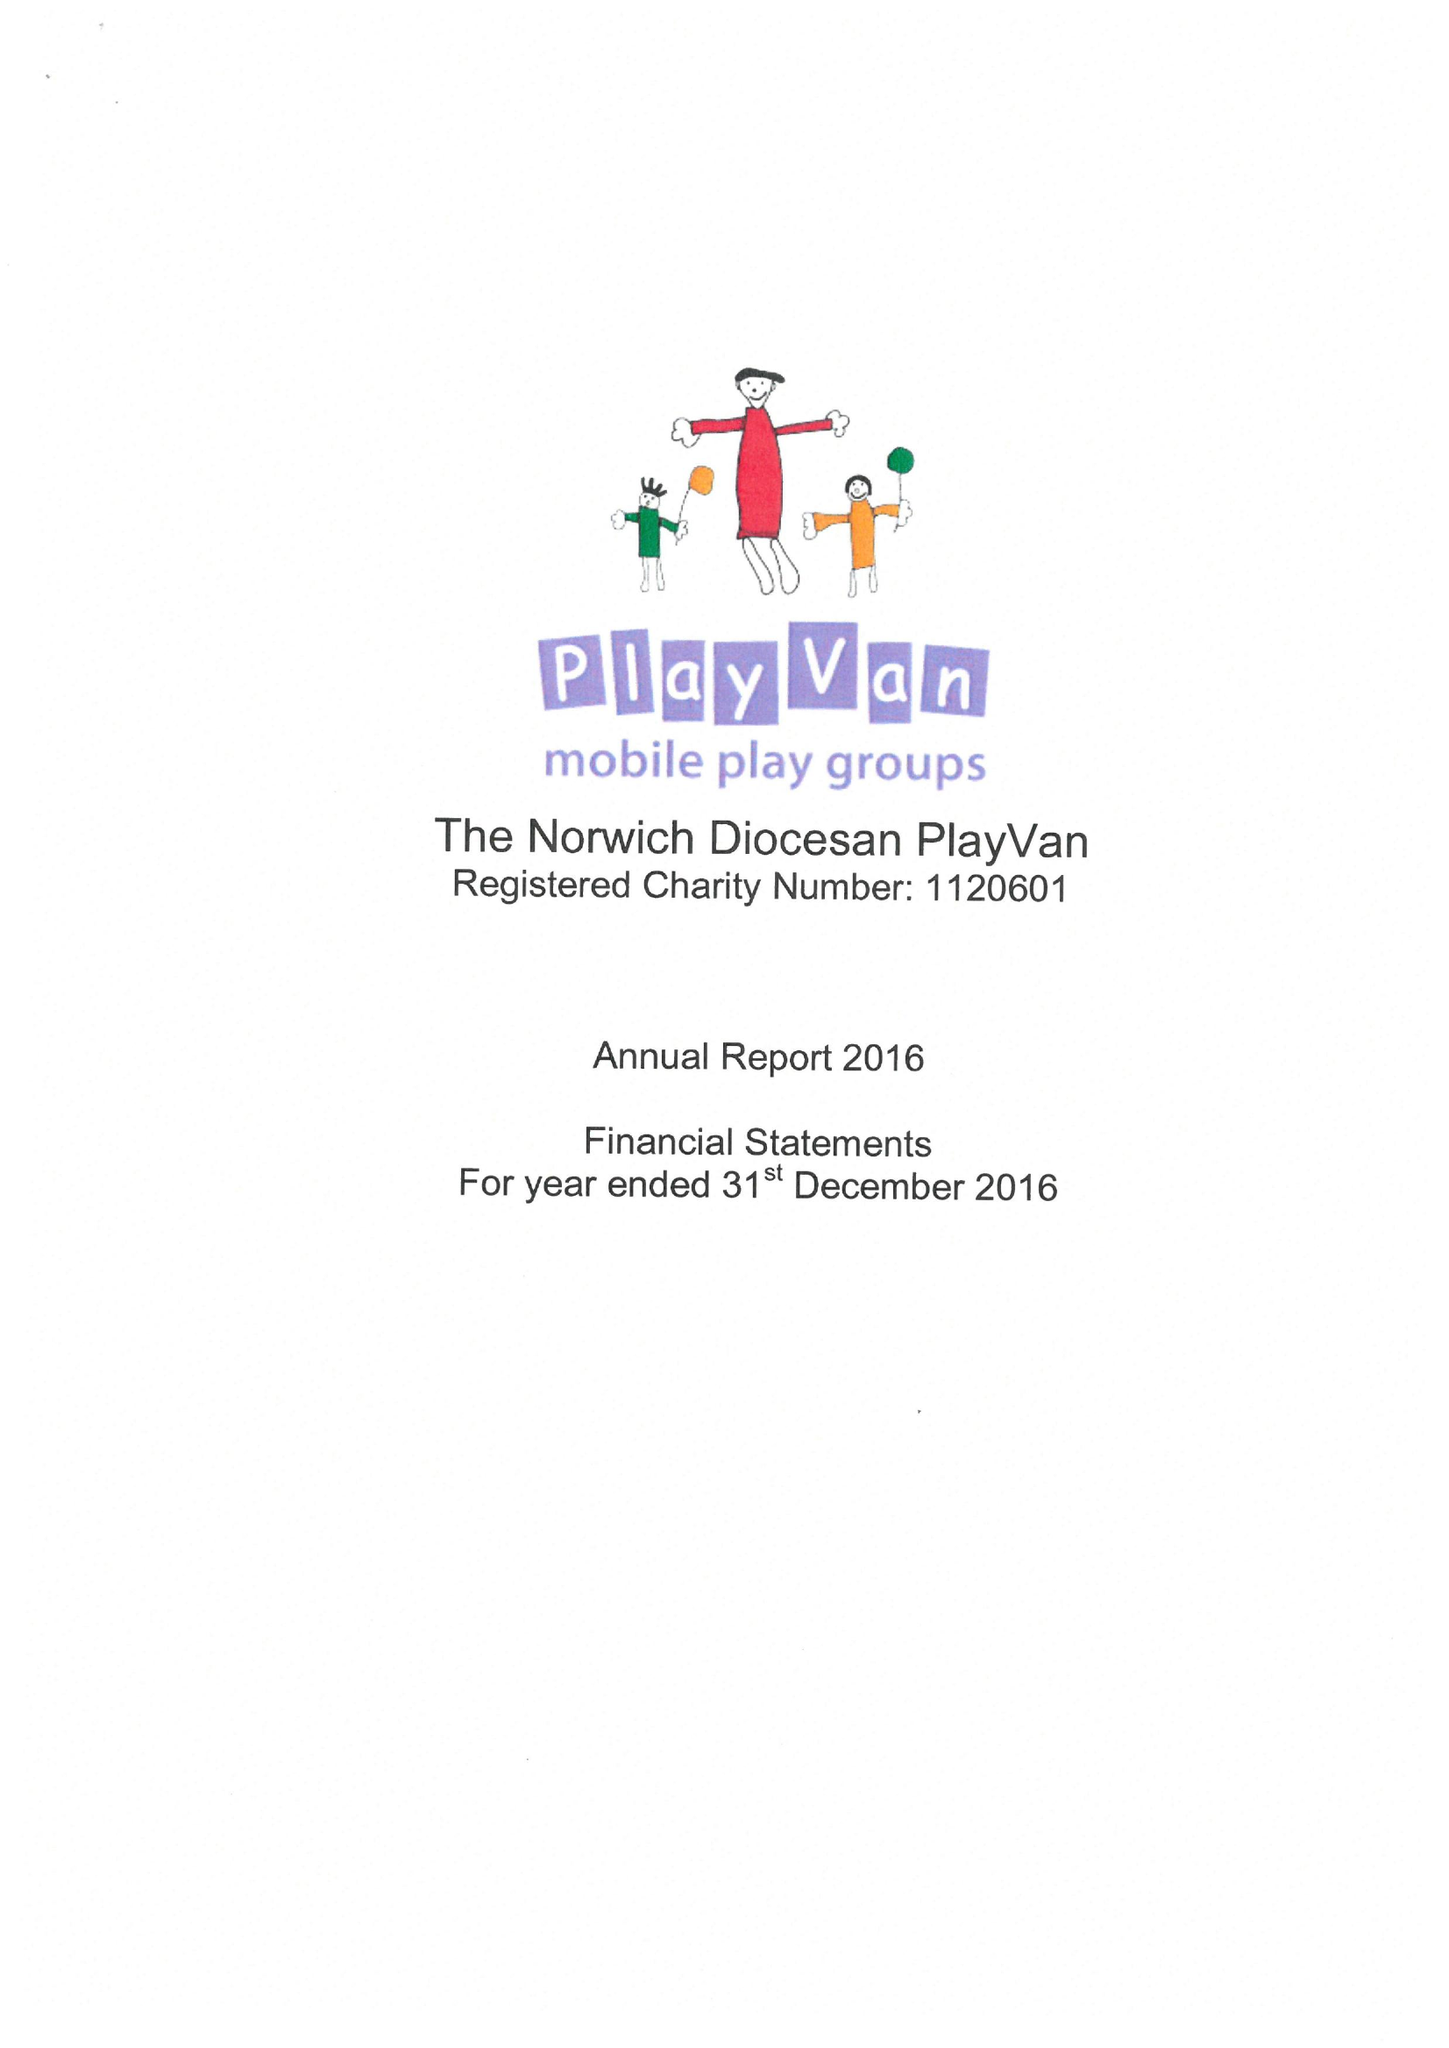What is the value for the charity_name?
Answer the question using a single word or phrase. The Norwich Diocesan Playvan 